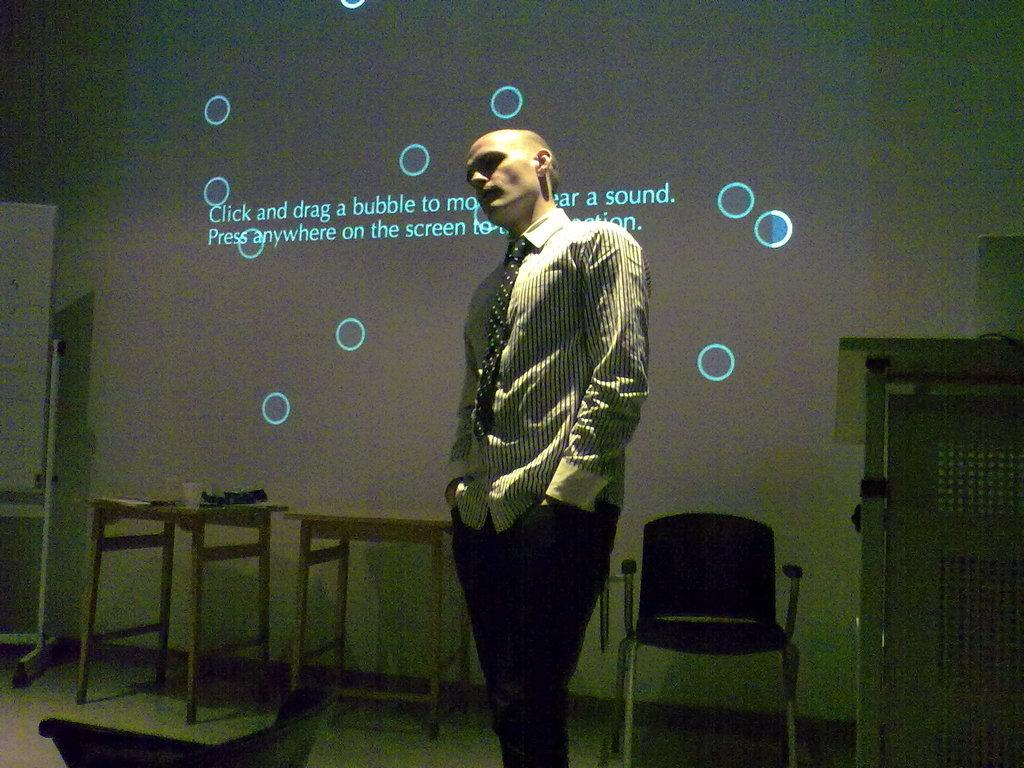What is the main subject in the image? There is a man standing in the image. What type of furniture is present in the image? There are tables in the image. Are there any seating options in the image? Yes, there is at least one chair in the image. What else can be seen on the floor in the image? There are other objects on the floor in the image. What type of mitten is the man wearing in the image? The man is not wearing a mitten in the image; he is not wearing any gloves or mittens. Can you tell me how many beads are on the floor in the image? There is no mention of beads in the image, so it is impossible to determine how many beads are on the floor. 